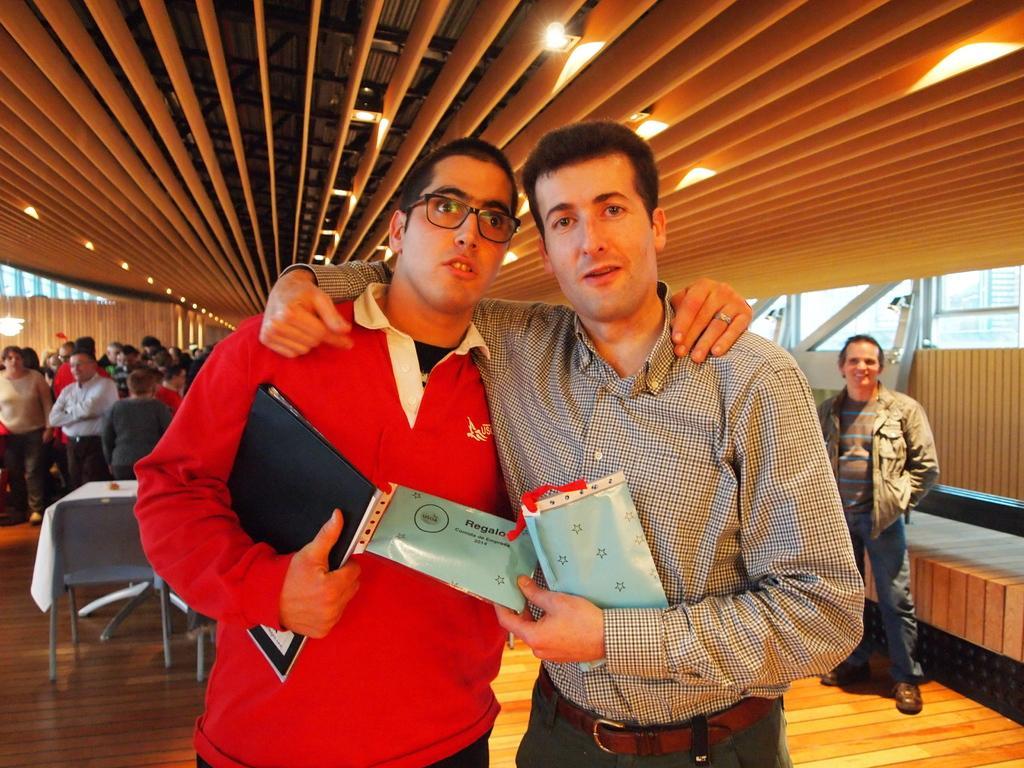In one or two sentences, can you explain what this image depicts? There are two men standing and holding something in the hands. One person is wearing specs. In the back there are many people. Also there is a table and chair. On the ceiling there are lights. On the sides there are walls. 